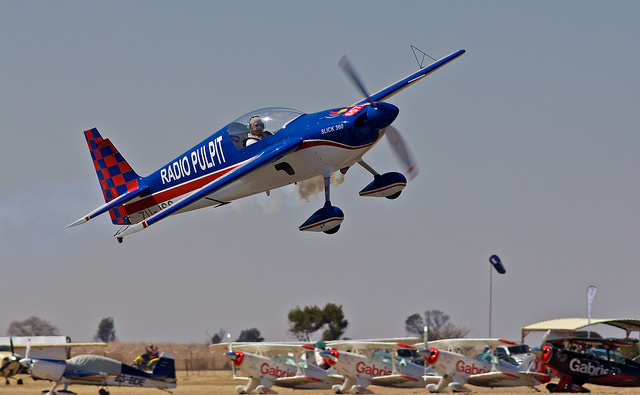Identify and read out the text in this image. RADIO PULPIT 711 Gabri Gabri 100 